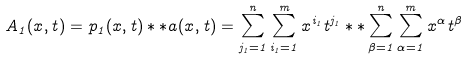<formula> <loc_0><loc_0><loc_500><loc_500>A _ { 1 } ( x , t ) = p _ { 1 } ( x , t ) \ast \ast a ( x , t ) = \sum _ { j _ { 1 } = 1 } ^ { n } \sum _ { i _ { 1 } = 1 } ^ { m } x ^ { i _ { 1 } } t ^ { j _ { 1 } } \ast \ast \sum _ { \beta = 1 } ^ { n } \sum _ { \alpha = 1 } ^ { m } x ^ { \alpha } t ^ { \beta }</formula> 